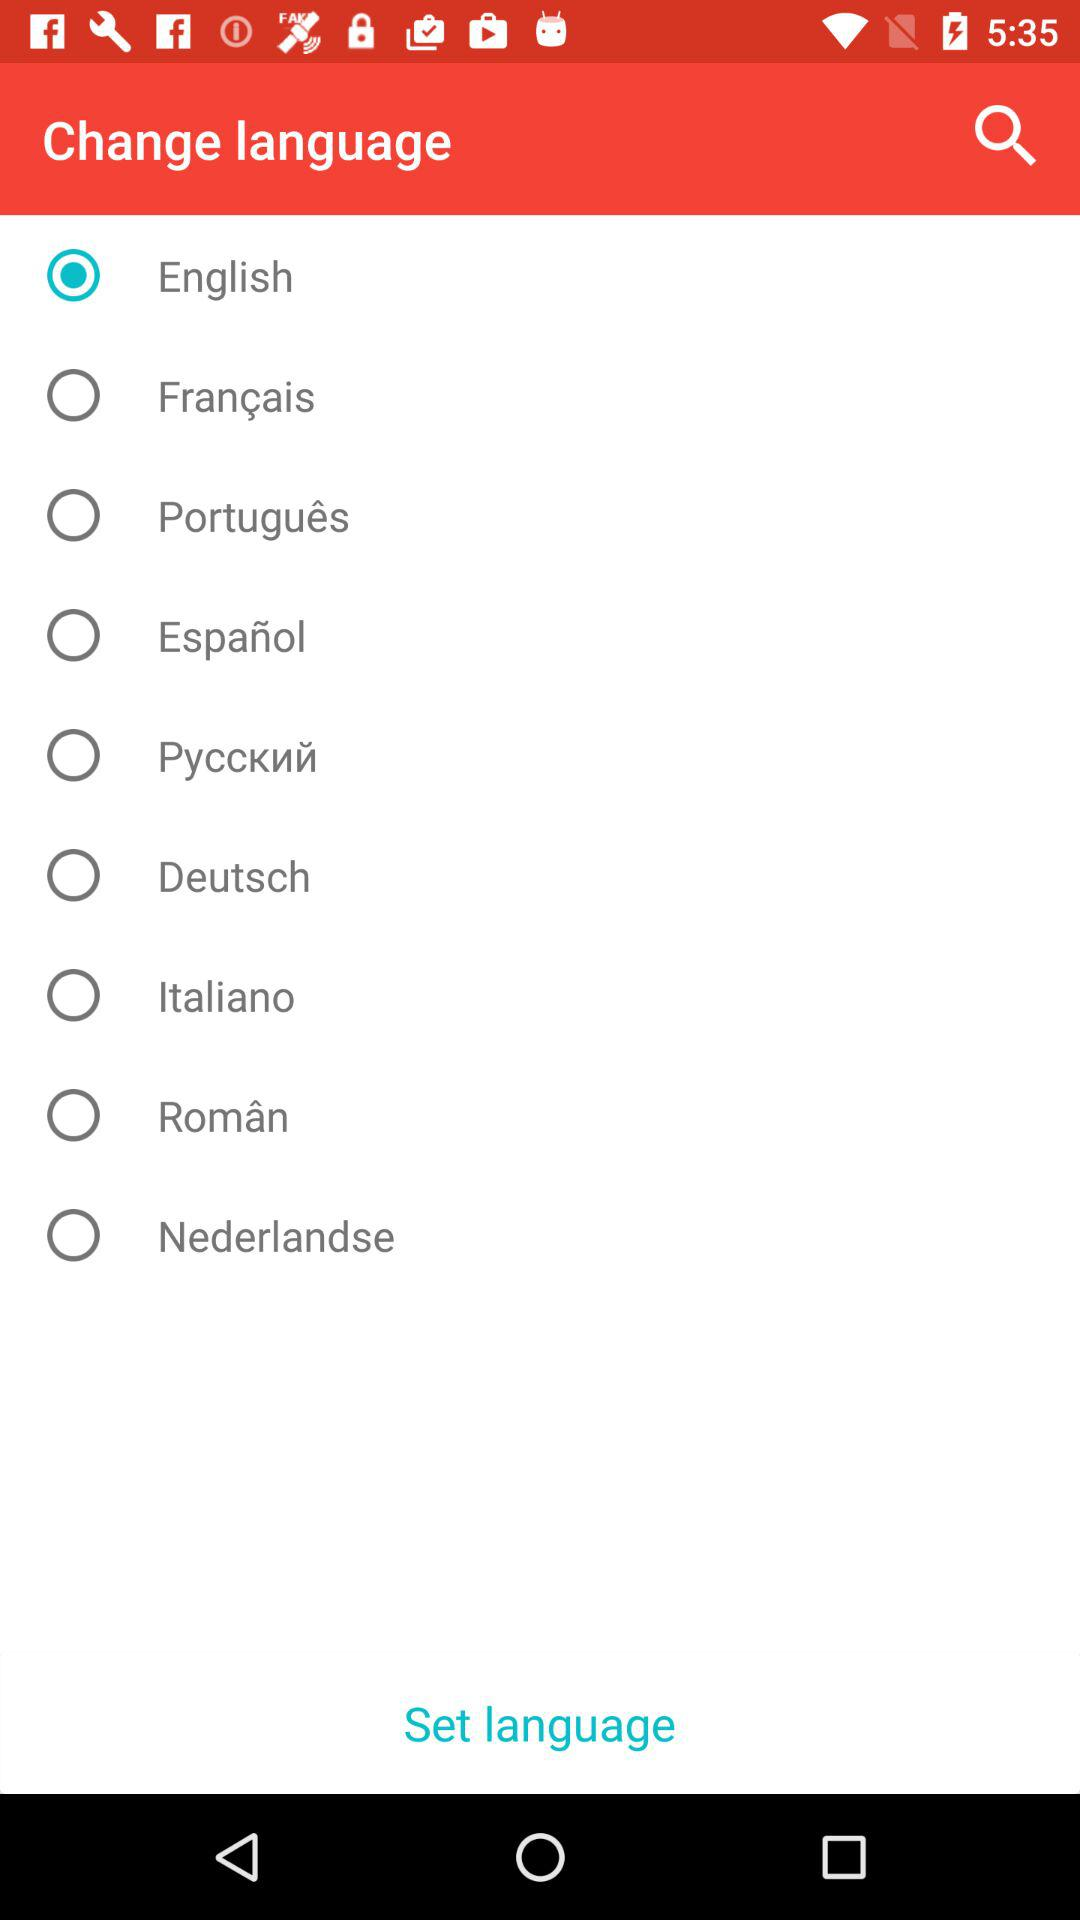What is the status of Français? The status is "off". 